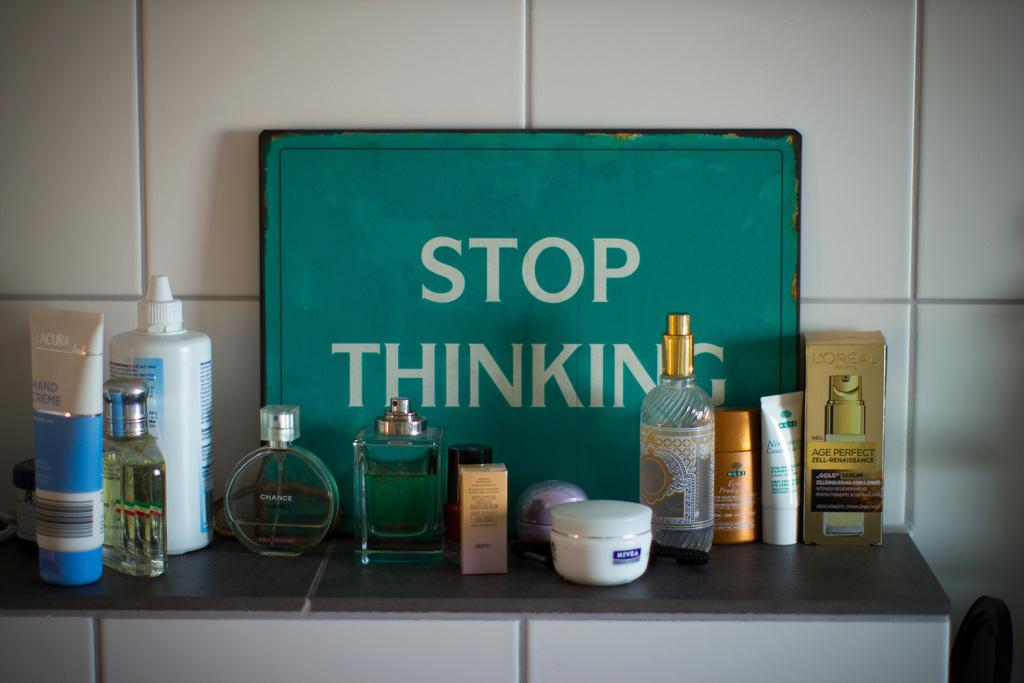<image>
Describe the image concisely. Bottles of beauty products in front of a sigh that says STOP THINKING. 